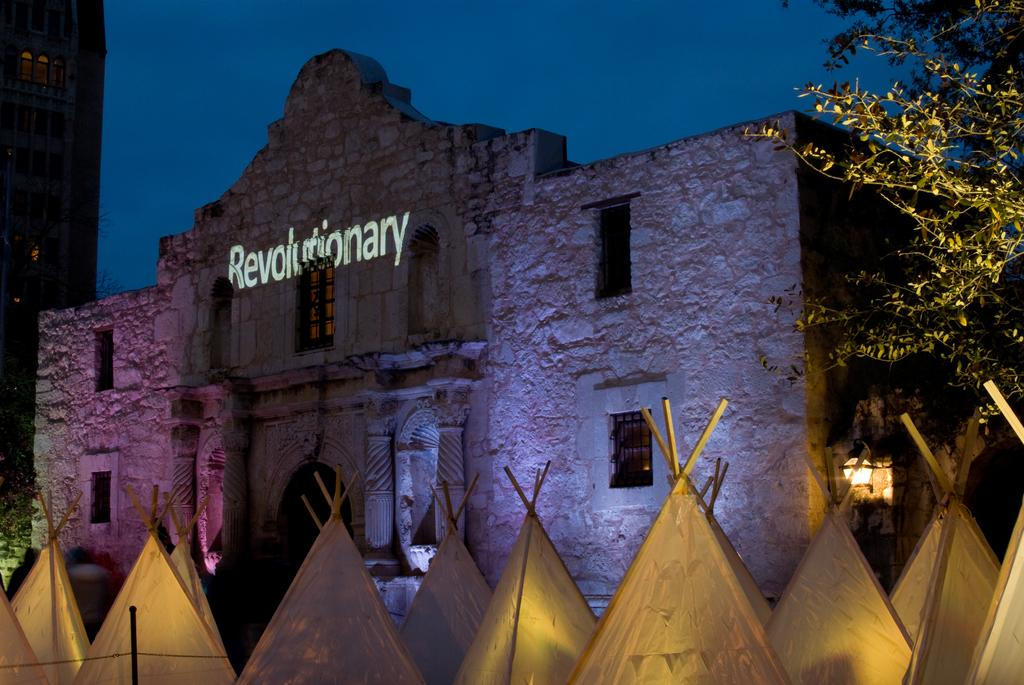<image>
Summarize the visual content of the image. A stone building has illuminated Revolutionary across the top. 